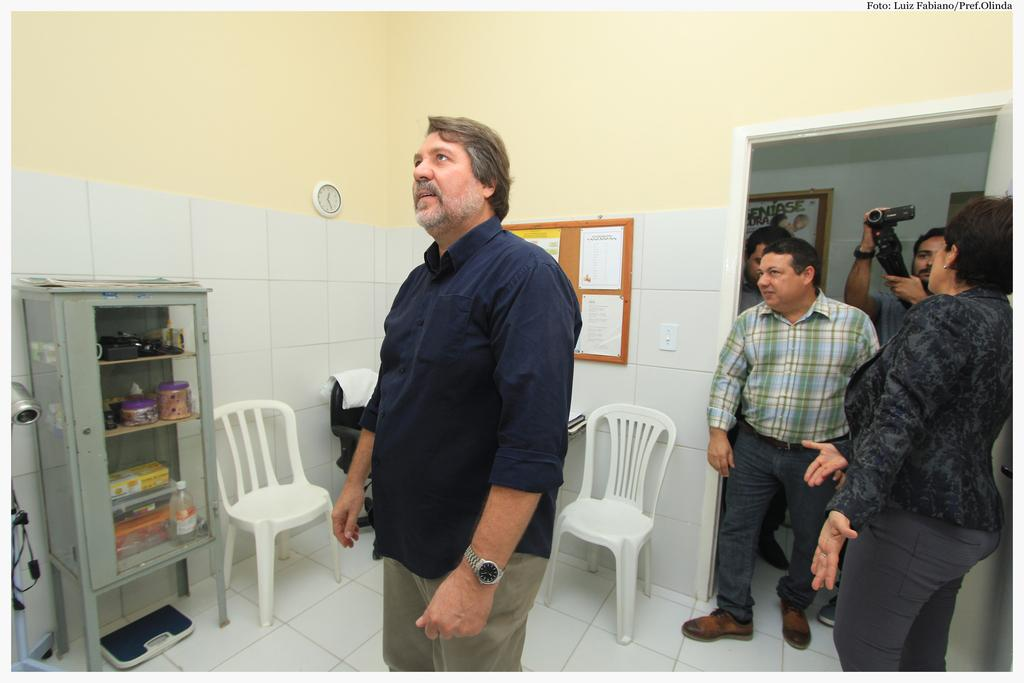What is the man in the room doing? The man is standing in the room and looking at something. Are there any other people in the room? No, there are no other people in the room besides the man. What can be found in the room besides the man? There are chairs and a cupboard with some items in the room. What is happening at the door in the image? There are men and a woman standing at the door. What type of surprise can be seen on the wrist of the man in the image? There is no surprise or wrist visible in the image; it only shows a man standing in the room and looking at something. 